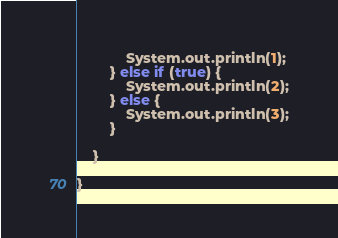<code> <loc_0><loc_0><loc_500><loc_500><_Java_>			System.out.println(1);
		} else if (true) {
			System.out.println(2);
		} else {
			System.out.println(3);
		}

	}

}
</code> 